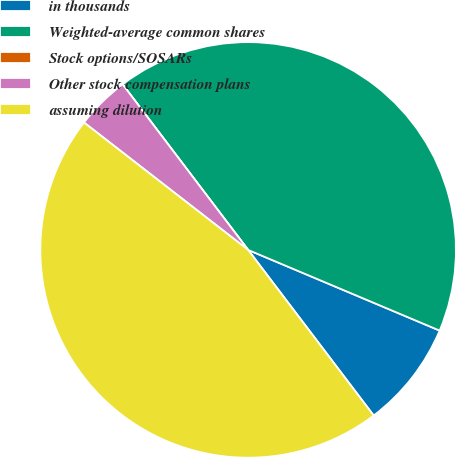Convert chart. <chart><loc_0><loc_0><loc_500><loc_500><pie_chart><fcel>in thousands<fcel>Weighted-average common shares<fcel>Stock options/SOSARs<fcel>Other stock compensation plans<fcel>assuming dilution<nl><fcel>8.33%<fcel>41.67%<fcel>0.0%<fcel>4.17%<fcel>45.83%<nl></chart> 